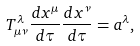Convert formula to latex. <formula><loc_0><loc_0><loc_500><loc_500>T _ { \mu \nu } ^ { \lambda } \frac { d x ^ { \mu } } { d \tau } \frac { d x ^ { \nu } } { d \tau } = a ^ { \lambda } ,</formula> 